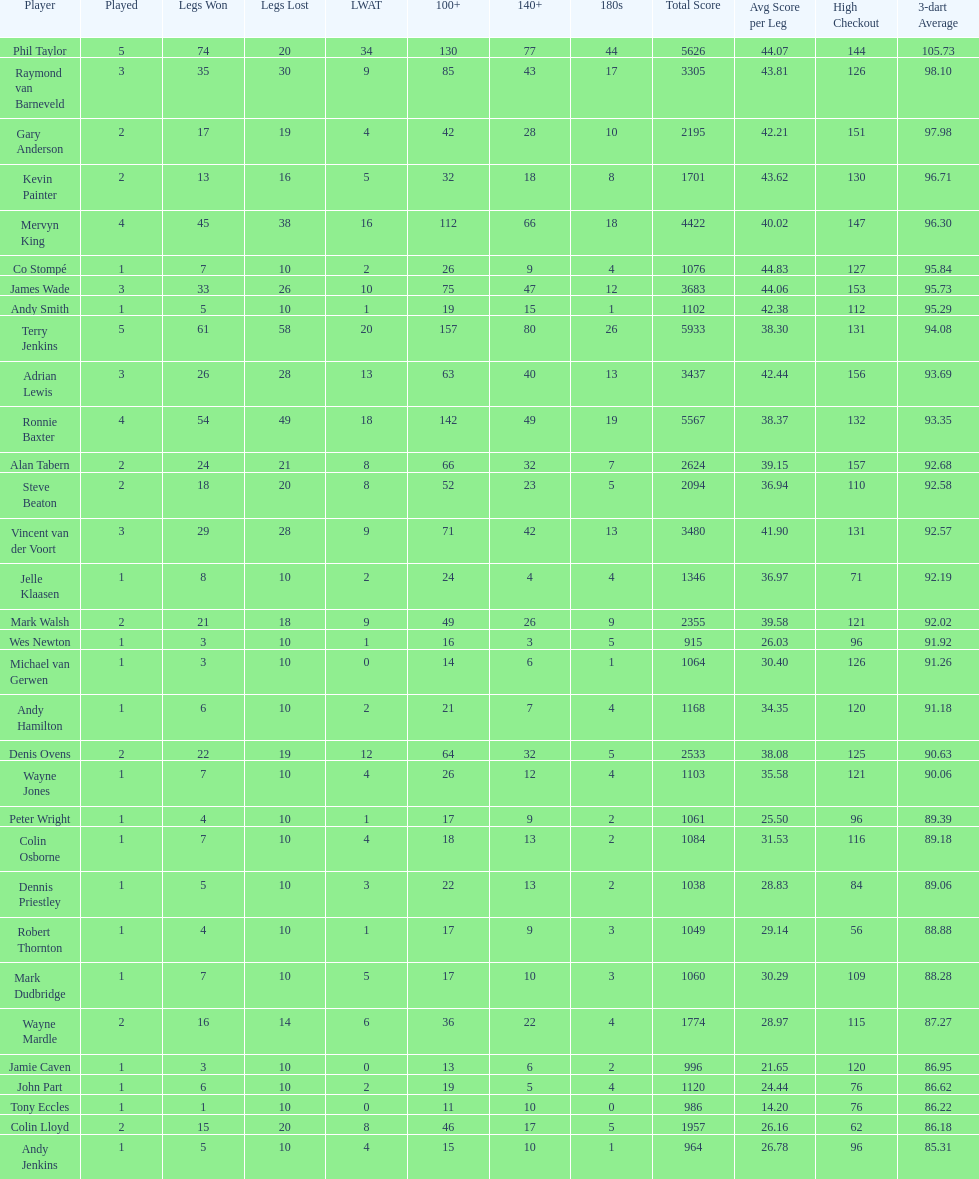How many players in the 2009 world matchplay won at least 30 legs? 6. I'm looking to parse the entire table for insights. Could you assist me with that? {'header': ['Player', 'Played', 'Legs Won', 'Legs Lost', 'LWAT', '100+', '140+', '180s', 'Total Score', 'Avg Score per Leg', 'High Checkout', '3-dart Average'], 'rows': [['Phil Taylor', '5', '74', '20', '34', '130', '77', '44', '5626', '44.07', '144', '105.73'], ['Raymond van Barneveld', '3', '35', '30', '9', '85', '43', '17', '3305', '43.81', '126', '98.10'], ['Gary Anderson', '2', '17', '19', '4', '42', '28', '10', '2195', '42.21', '151', '97.98'], ['Kevin Painter', '2', '13', '16', '5', '32', '18', '8', '1701', '43.62', '130', '96.71'], ['Mervyn King', '4', '45', '38', '16', '112', '66', '18', '4422', '40.02', '147', '96.30'], ['Co Stompé', '1', '7', '10', '2', '26', '9', '4', '1076', '44.83', '127', '95.84'], ['James Wade', '3', '33', '26', '10', '75', '47', '12', '3683', '44.06', '153', '95.73'], ['Andy Smith', '1', '5', '10', '1', '19', '15', '1', '1102', '42.38', '112', '95.29'], ['Terry Jenkins', '5', '61', '58', '20', '157', '80', '26', '5933', '38.30', '131', '94.08'], ['Adrian Lewis', '3', '26', '28', '13', '63', '40', '13', '3437', '42.44', '156', '93.69'], ['Ronnie Baxter', '4', '54', '49', '18', '142', '49', '19', '5567', '38.37', '132', '93.35'], ['Alan Tabern', '2', '24', '21', '8', '66', '32', '7', '2624', '39.15', '157', '92.68'], ['Steve Beaton', '2', '18', '20', '8', '52', '23', '5', '2094', '36.94', '110', '92.58'], ['Vincent van der Voort', '3', '29', '28', '9', '71', '42', '13', '3480', '41.90', '131', '92.57'], ['Jelle Klaasen', '1', '8', '10', '2', '24', '4', '4', '1346', '36.97', '71', '92.19'], ['Mark Walsh', '2', '21', '18', '9', '49', '26', '9', '2355', '39.58', '121', '92.02'], ['Wes Newton', '1', '3', '10', '1', '16', '3', '5', '915', '26.03', '96', '91.92'], ['Michael van Gerwen', '1', '3', '10', '0', '14', '6', '1', '1064', '30.40', '126', '91.26'], ['Andy Hamilton', '1', '6', '10', '2', '21', '7', '4', '1168', '34.35', '120', '91.18'], ['Denis Ovens', '2', '22', '19', '12', '64', '32', '5', '2533', '38.08', '125', '90.63'], ['Wayne Jones', '1', '7', '10', '4', '26', '12', '4', '1103', '35.58', '121', '90.06'], ['Peter Wright', '1', '4', '10', '1', '17', '9', '2', '1061', '25.50', '96', '89.39'], ['Colin Osborne', '1', '7', '10', '4', '18', '13', '2', '1084', '31.53', '116', '89.18'], ['Dennis Priestley', '1', '5', '10', '3', '22', '13', '2', '1038', '28.83', '84', '89.06'], ['Robert Thornton', '1', '4', '10', '1', '17', '9', '3', '1049', '29.14', '56', '88.88'], ['Mark Dudbridge', '1', '7', '10', '5', '17', '10', '3', '1060', '30.29', '109', '88.28'], ['Wayne Mardle', '2', '16', '14', '6', '36', '22', '4', '1774', '28.97', '115', '87.27'], ['Jamie Caven', '1', '3', '10', '0', '13', '6', '2', '996', '21.65', '120', '86.95'], ['John Part', '1', '6', '10', '2', '19', '5', '4', '1120', '24.44', '76', '86.62'], ['Tony Eccles', '1', '1', '10', '0', '11', '10', '0', '986', '14.20', '76', '86.22'], ['Colin Lloyd', '2', '15', '20', '8', '46', '17', '5', '1957', '26.16', '62', '86.18'], ['Andy Jenkins', '1', '5', '10', '4', '15', '10', '1', '964', '26.78', '96', '85.31']]} 